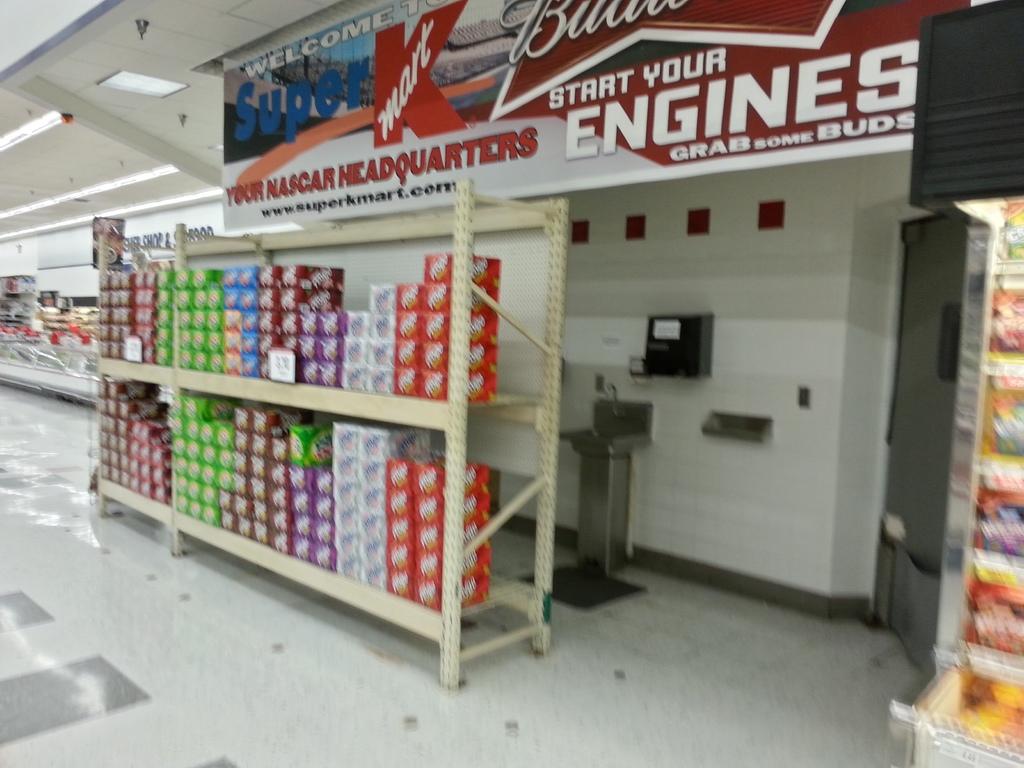What beer brand is advertised?
Provide a succinct answer. Budweiser. Is this a super k?
Ensure brevity in your answer.  Yes. 